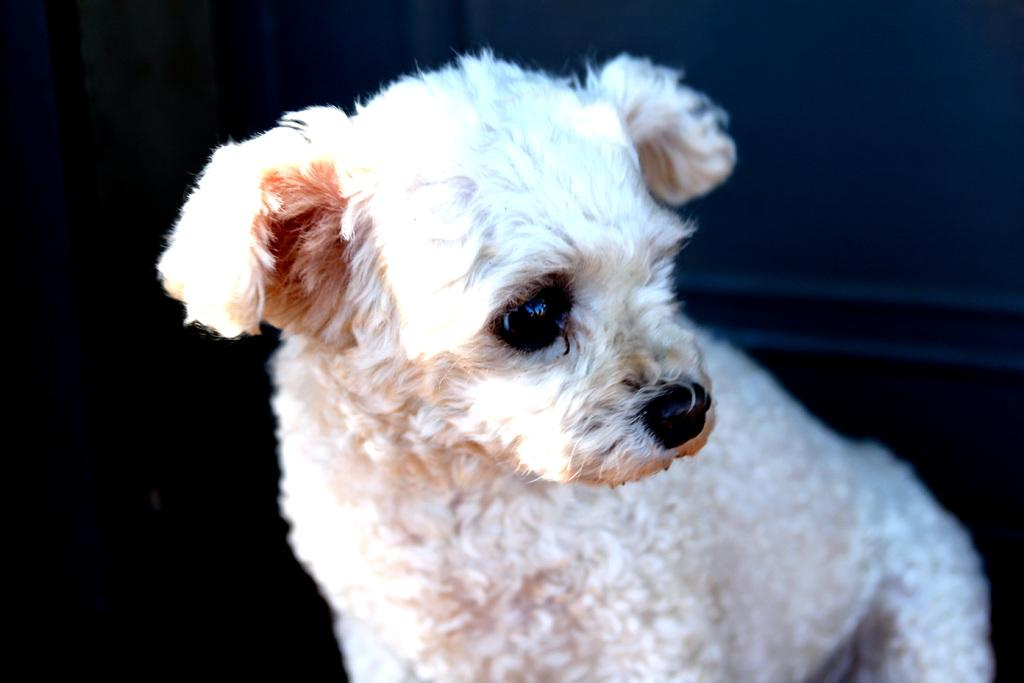What type of animal is present in the image? There is a dog in the image. What type of blade is the dog using to cut the vegetables in the image? There is no blade or vegetables present in the image; it features a dog. 